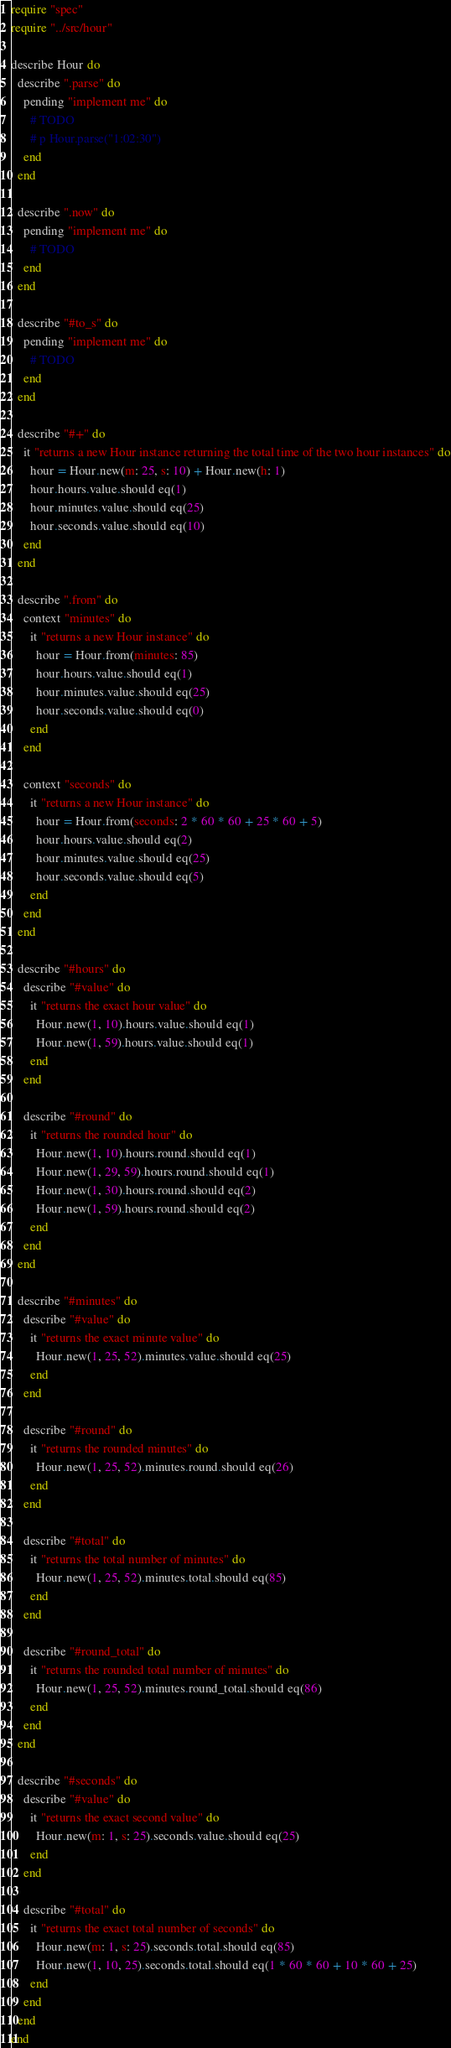Convert code to text. <code><loc_0><loc_0><loc_500><loc_500><_Crystal_>require "spec"
require "../src/hour"

describe Hour do
  describe ".parse" do
    pending "implement me" do
      # TODO
      # p Hour.parse("1:02:30")
    end
  end

  describe ".now" do
    pending "implement me" do
      # TODO
    end
  end

  describe "#to_s" do
    pending "implement me" do
      # TODO
    end
  end

  describe "#+" do
    it "returns a new Hour instance returning the total time of the two hour instances" do
      hour = Hour.new(m: 25, s: 10) + Hour.new(h: 1)
      hour.hours.value.should eq(1)
      hour.minutes.value.should eq(25)
      hour.seconds.value.should eq(10)
    end
  end

  describe ".from" do
    context "minutes" do
      it "returns a new Hour instance" do
        hour = Hour.from(minutes: 85)
        hour.hours.value.should eq(1)
        hour.minutes.value.should eq(25)
        hour.seconds.value.should eq(0)
      end
    end

    context "seconds" do
      it "returns a new Hour instance" do
        hour = Hour.from(seconds: 2 * 60 * 60 + 25 * 60 + 5)
        hour.hours.value.should eq(2)
        hour.minutes.value.should eq(25)
        hour.seconds.value.should eq(5)
      end
    end
  end

  describe "#hours" do
    describe "#value" do
      it "returns the exact hour value" do
        Hour.new(1, 10).hours.value.should eq(1)
        Hour.new(1, 59).hours.value.should eq(1)
      end
    end

    describe "#round" do
      it "returns the rounded hour" do
        Hour.new(1, 10).hours.round.should eq(1)
        Hour.new(1, 29, 59).hours.round.should eq(1)
        Hour.new(1, 30).hours.round.should eq(2)
        Hour.new(1, 59).hours.round.should eq(2)
      end
    end
  end

  describe "#minutes" do
    describe "#value" do
      it "returns the exact minute value" do
        Hour.new(1, 25, 52).minutes.value.should eq(25)
      end
    end

    describe "#round" do
      it "returns the rounded minutes" do
        Hour.new(1, 25, 52).minutes.round.should eq(26)
      end
    end

    describe "#total" do
      it "returns the total number of minutes" do
        Hour.new(1, 25, 52).minutes.total.should eq(85)
      end
    end

    describe "#round_total" do
      it "returns the rounded total number of minutes" do
        Hour.new(1, 25, 52).minutes.round_total.should eq(86)
      end
    end
  end

  describe "#seconds" do
    describe "#value" do
      it "returns the exact second value" do
        Hour.new(m: 1, s: 25).seconds.value.should eq(25)
      end
    end

    describe "#total" do
      it "returns the exact total number of seconds" do
        Hour.new(m: 1, s: 25).seconds.total.should eq(85)
        Hour.new(1, 10, 25).seconds.total.should eq(1 * 60 * 60 + 10 * 60 + 25)
      end
    end
  end
end
</code> 